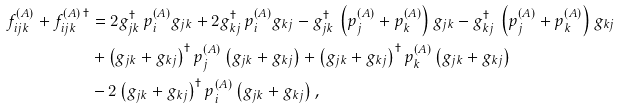<formula> <loc_0><loc_0><loc_500><loc_500>f ^ { ( A ) } _ { i j k } + f ^ { ( A ) \, \dagger } _ { i j k } & = 2 g _ { j k } ^ { \dagger } \, p ^ { ( A ) } _ { i } g _ { j k } + 2 g _ { k j } ^ { \dagger } \, p ^ { ( A ) } _ { i } g _ { k j } - g _ { j k } ^ { \dagger } \, \left ( p ^ { ( A ) } _ { j } + p ^ { ( A ) } _ { k } \right ) g _ { j k } - g _ { k j } ^ { \dagger } \, \left ( p ^ { ( A ) } _ { j } + p ^ { ( A ) } _ { k } \right ) g _ { k j } \\ & + \left ( g _ { j k } + g _ { k j } \right ) ^ { \dagger } p ^ { ( A ) } _ { j } \left ( g _ { j k } + g _ { k j } \right ) + \left ( g _ { j k } + g _ { k j } \right ) ^ { \dagger } p ^ { ( A ) } _ { k } \left ( g _ { j k } + g _ { k j } \right ) \\ & - 2 \left ( g _ { j k } + g _ { k j } \right ) ^ { \dagger } p ^ { ( A ) } _ { i } \left ( g _ { j k } + g _ { k j } \right ) ,</formula> 